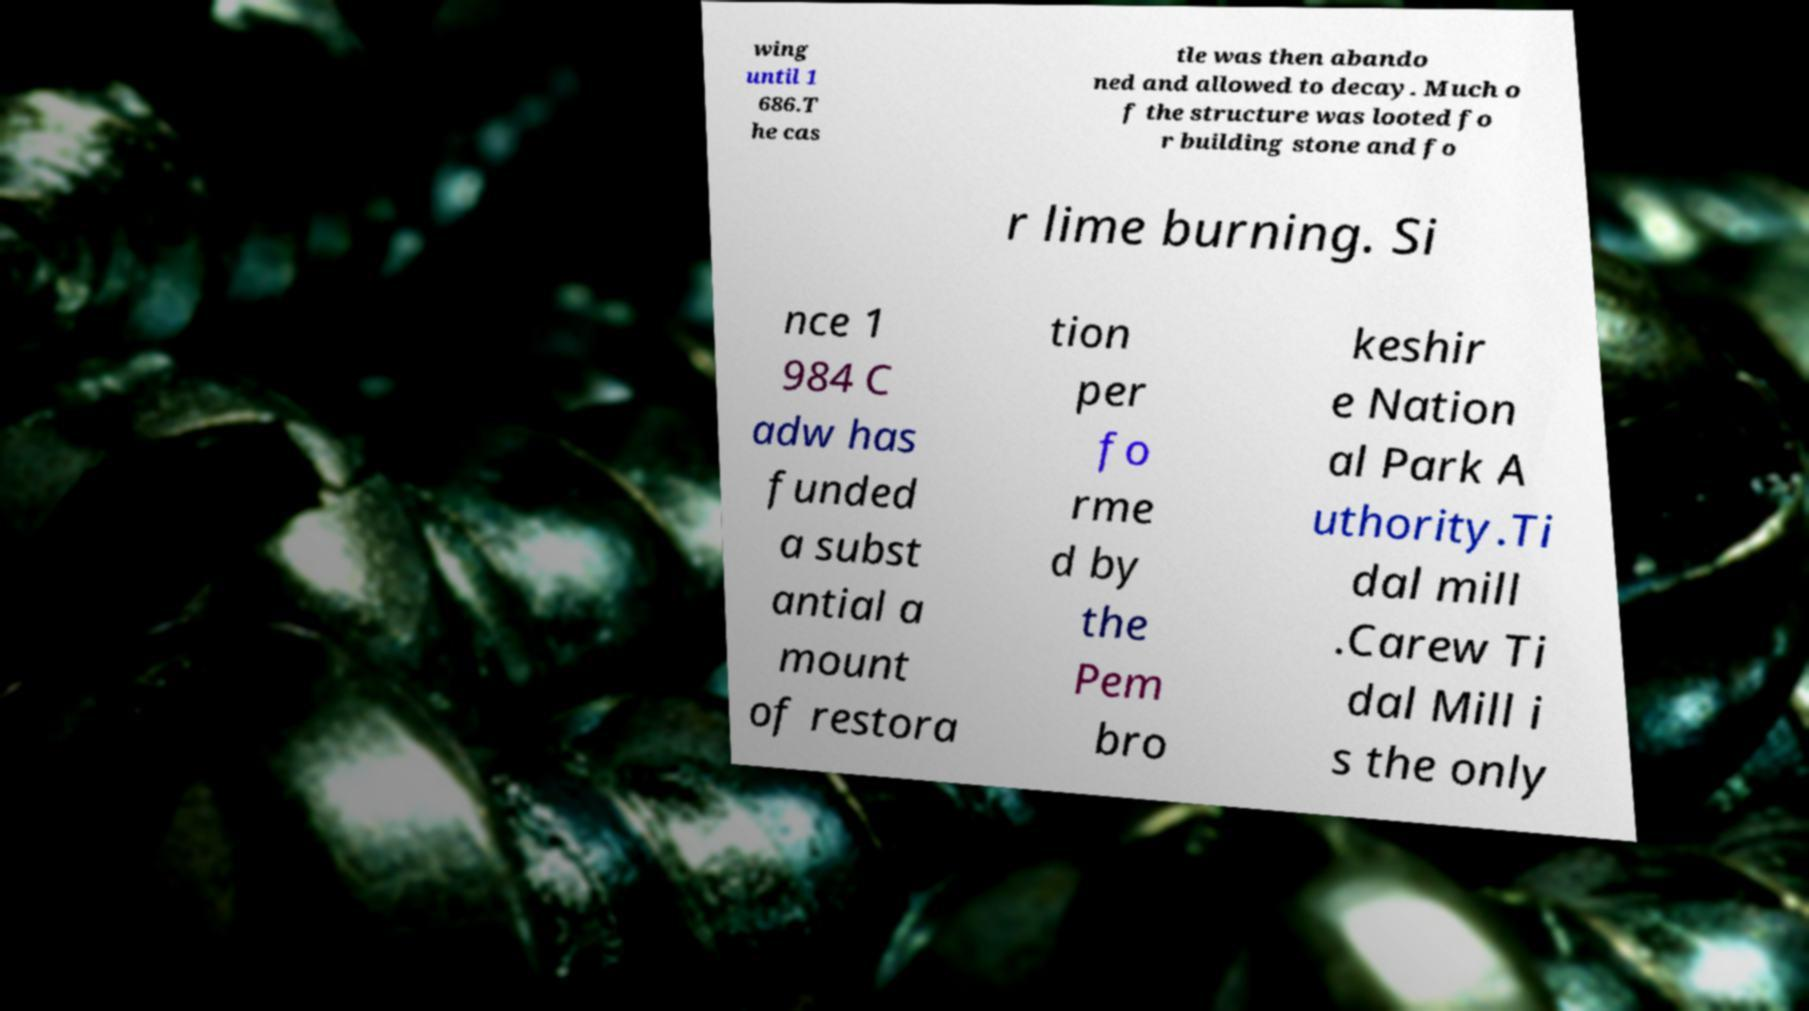Can you read and provide the text displayed in the image?This photo seems to have some interesting text. Can you extract and type it out for me? wing until 1 686.T he cas tle was then abando ned and allowed to decay. Much o f the structure was looted fo r building stone and fo r lime burning. Si nce 1 984 C adw has funded a subst antial a mount of restora tion per fo rme d by the Pem bro keshir e Nation al Park A uthority.Ti dal mill .Carew Ti dal Mill i s the only 